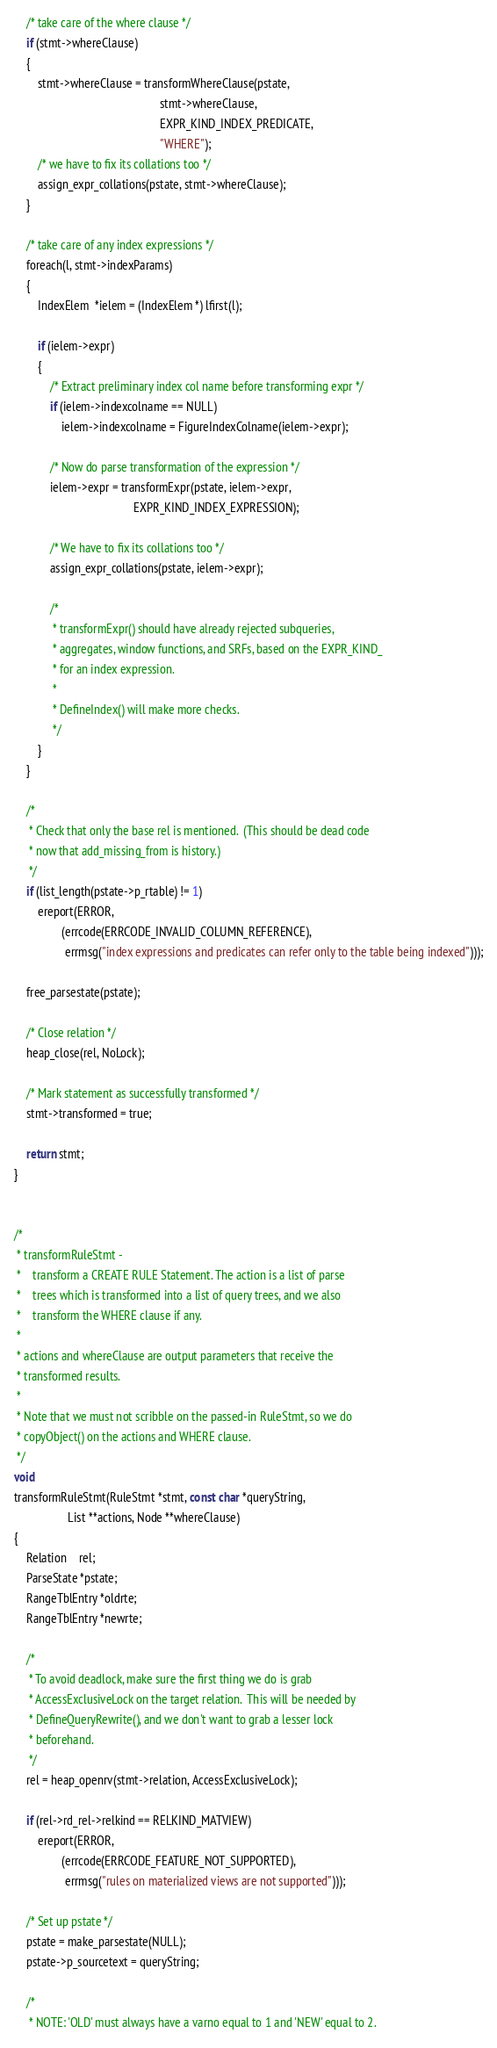Convert code to text. <code><loc_0><loc_0><loc_500><loc_500><_C_>
	/* take care of the where clause */
	if (stmt->whereClause)
	{
		stmt->whereClause = transformWhereClause(pstate,
												 stmt->whereClause,
												 EXPR_KIND_INDEX_PREDICATE,
												 "WHERE");
		/* we have to fix its collations too */
		assign_expr_collations(pstate, stmt->whereClause);
	}

	/* take care of any index expressions */
	foreach(l, stmt->indexParams)
	{
		IndexElem  *ielem = (IndexElem *) lfirst(l);

		if (ielem->expr)
		{
			/* Extract preliminary index col name before transforming expr */
			if (ielem->indexcolname == NULL)
				ielem->indexcolname = FigureIndexColname(ielem->expr);

			/* Now do parse transformation of the expression */
			ielem->expr = transformExpr(pstate, ielem->expr,
										EXPR_KIND_INDEX_EXPRESSION);

			/* We have to fix its collations too */
			assign_expr_collations(pstate, ielem->expr);

			/*
			 * transformExpr() should have already rejected subqueries,
			 * aggregates, window functions, and SRFs, based on the EXPR_KIND_
			 * for an index expression.
			 *
			 * DefineIndex() will make more checks.
			 */
		}
	}

	/*
	 * Check that only the base rel is mentioned.  (This should be dead code
	 * now that add_missing_from is history.)
	 */
	if (list_length(pstate->p_rtable) != 1)
		ereport(ERROR,
				(errcode(ERRCODE_INVALID_COLUMN_REFERENCE),
				 errmsg("index expressions and predicates can refer only to the table being indexed")));

	free_parsestate(pstate);

	/* Close relation */
	heap_close(rel, NoLock);

	/* Mark statement as successfully transformed */
	stmt->transformed = true;

	return stmt;
}


/*
 * transformRuleStmt -
 *	  transform a CREATE RULE Statement. The action is a list of parse
 *	  trees which is transformed into a list of query trees, and we also
 *	  transform the WHERE clause if any.
 *
 * actions and whereClause are output parameters that receive the
 * transformed results.
 *
 * Note that we must not scribble on the passed-in RuleStmt, so we do
 * copyObject() on the actions and WHERE clause.
 */
void
transformRuleStmt(RuleStmt *stmt, const char *queryString,
				  List **actions, Node **whereClause)
{
	Relation	rel;
	ParseState *pstate;
	RangeTblEntry *oldrte;
	RangeTblEntry *newrte;

	/*
	 * To avoid deadlock, make sure the first thing we do is grab
	 * AccessExclusiveLock on the target relation.  This will be needed by
	 * DefineQueryRewrite(), and we don't want to grab a lesser lock
	 * beforehand.
	 */
	rel = heap_openrv(stmt->relation, AccessExclusiveLock);

	if (rel->rd_rel->relkind == RELKIND_MATVIEW)
		ereport(ERROR,
				(errcode(ERRCODE_FEATURE_NOT_SUPPORTED),
				 errmsg("rules on materialized views are not supported")));

	/* Set up pstate */
	pstate = make_parsestate(NULL);
	pstate->p_sourcetext = queryString;

	/*
	 * NOTE: 'OLD' must always have a varno equal to 1 and 'NEW' equal to 2.</code> 